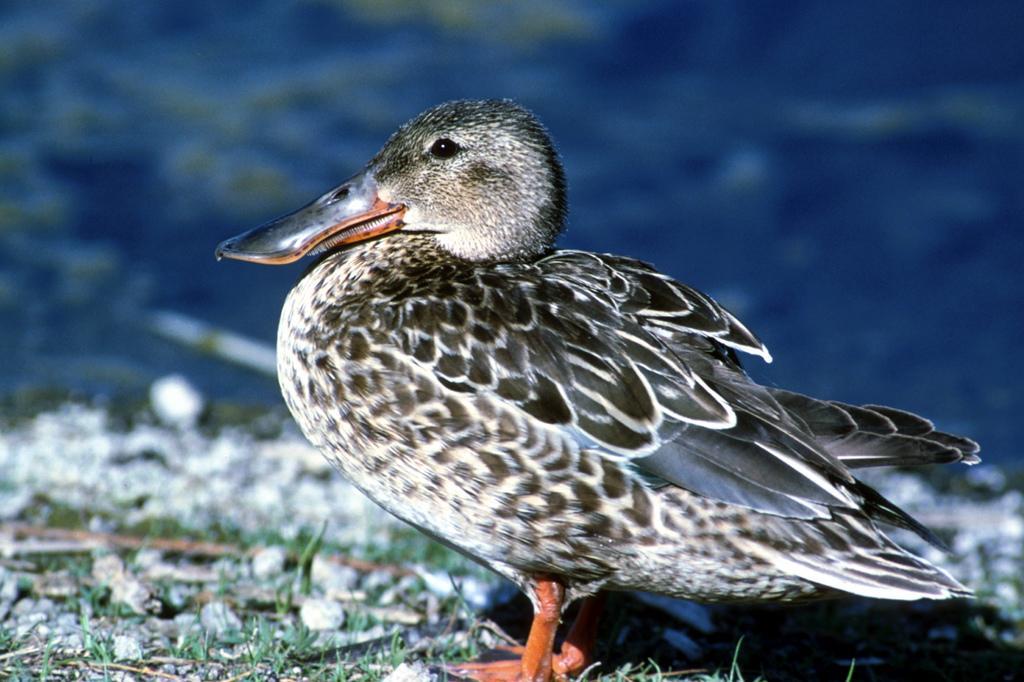Could you give a brief overview of what you see in this image? In this picture I can see a duck and grass on the ground and I can see blurry background. 